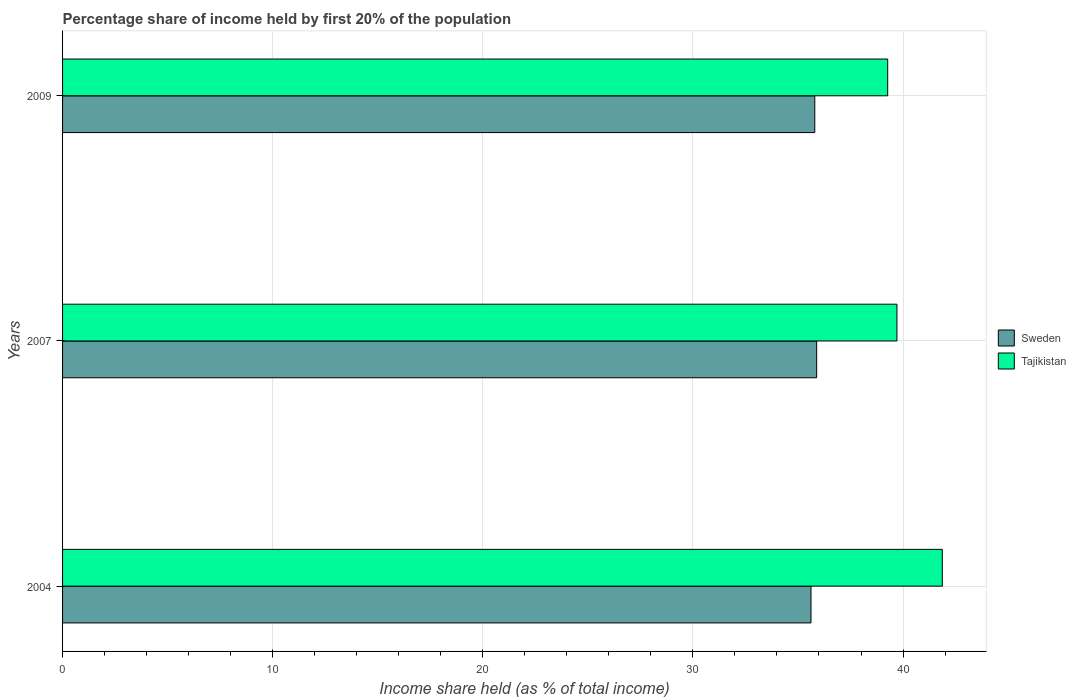Are the number of bars per tick equal to the number of legend labels?
Offer a terse response. Yes. What is the label of the 1st group of bars from the top?
Give a very brief answer. 2009. What is the share of income held by first 20% of the population in Sweden in 2004?
Offer a very short reply. 35.62. Across all years, what is the maximum share of income held by first 20% of the population in Sweden?
Provide a succinct answer. 35.89. Across all years, what is the minimum share of income held by first 20% of the population in Tajikistan?
Keep it short and to the point. 39.27. What is the total share of income held by first 20% of the population in Sweden in the graph?
Offer a terse response. 107.31. What is the difference between the share of income held by first 20% of the population in Tajikistan in 2004 and that in 2009?
Ensure brevity in your answer.  2.6. What is the difference between the share of income held by first 20% of the population in Tajikistan in 2009 and the share of income held by first 20% of the population in Sweden in 2007?
Give a very brief answer. 3.38. What is the average share of income held by first 20% of the population in Sweden per year?
Your response must be concise. 35.77. In the year 2009, what is the difference between the share of income held by first 20% of the population in Sweden and share of income held by first 20% of the population in Tajikistan?
Provide a succinct answer. -3.47. What is the ratio of the share of income held by first 20% of the population in Tajikistan in 2007 to that in 2009?
Provide a short and direct response. 1.01. Is the share of income held by first 20% of the population in Tajikistan in 2007 less than that in 2009?
Keep it short and to the point. No. What is the difference between the highest and the second highest share of income held by first 20% of the population in Tajikistan?
Provide a succinct answer. 2.16. What is the difference between the highest and the lowest share of income held by first 20% of the population in Sweden?
Your answer should be very brief. 0.27. In how many years, is the share of income held by first 20% of the population in Tajikistan greater than the average share of income held by first 20% of the population in Tajikistan taken over all years?
Make the answer very short. 1. Is the sum of the share of income held by first 20% of the population in Sweden in 2004 and 2009 greater than the maximum share of income held by first 20% of the population in Tajikistan across all years?
Provide a short and direct response. Yes. What does the 1st bar from the bottom in 2007 represents?
Provide a succinct answer. Sweden. How many bars are there?
Offer a terse response. 6. What is the difference between two consecutive major ticks on the X-axis?
Make the answer very short. 10. How are the legend labels stacked?
Offer a very short reply. Vertical. What is the title of the graph?
Give a very brief answer. Percentage share of income held by first 20% of the population. Does "Estonia" appear as one of the legend labels in the graph?
Make the answer very short. No. What is the label or title of the X-axis?
Offer a terse response. Income share held (as % of total income). What is the label or title of the Y-axis?
Make the answer very short. Years. What is the Income share held (as % of total income) of Sweden in 2004?
Your answer should be compact. 35.62. What is the Income share held (as % of total income) in Tajikistan in 2004?
Your answer should be very brief. 41.87. What is the Income share held (as % of total income) of Sweden in 2007?
Make the answer very short. 35.89. What is the Income share held (as % of total income) of Tajikistan in 2007?
Your answer should be compact. 39.71. What is the Income share held (as % of total income) of Sweden in 2009?
Keep it short and to the point. 35.8. What is the Income share held (as % of total income) in Tajikistan in 2009?
Give a very brief answer. 39.27. Across all years, what is the maximum Income share held (as % of total income) in Sweden?
Your answer should be compact. 35.89. Across all years, what is the maximum Income share held (as % of total income) in Tajikistan?
Offer a terse response. 41.87. Across all years, what is the minimum Income share held (as % of total income) in Sweden?
Ensure brevity in your answer.  35.62. Across all years, what is the minimum Income share held (as % of total income) in Tajikistan?
Make the answer very short. 39.27. What is the total Income share held (as % of total income) in Sweden in the graph?
Your response must be concise. 107.31. What is the total Income share held (as % of total income) of Tajikistan in the graph?
Offer a terse response. 120.85. What is the difference between the Income share held (as % of total income) in Sweden in 2004 and that in 2007?
Your answer should be very brief. -0.27. What is the difference between the Income share held (as % of total income) in Tajikistan in 2004 and that in 2007?
Make the answer very short. 2.16. What is the difference between the Income share held (as % of total income) of Sweden in 2004 and that in 2009?
Offer a terse response. -0.18. What is the difference between the Income share held (as % of total income) of Sweden in 2007 and that in 2009?
Make the answer very short. 0.09. What is the difference between the Income share held (as % of total income) of Tajikistan in 2007 and that in 2009?
Ensure brevity in your answer.  0.44. What is the difference between the Income share held (as % of total income) of Sweden in 2004 and the Income share held (as % of total income) of Tajikistan in 2007?
Ensure brevity in your answer.  -4.09. What is the difference between the Income share held (as % of total income) in Sweden in 2004 and the Income share held (as % of total income) in Tajikistan in 2009?
Provide a short and direct response. -3.65. What is the difference between the Income share held (as % of total income) of Sweden in 2007 and the Income share held (as % of total income) of Tajikistan in 2009?
Offer a very short reply. -3.38. What is the average Income share held (as % of total income) in Sweden per year?
Provide a succinct answer. 35.77. What is the average Income share held (as % of total income) in Tajikistan per year?
Your answer should be compact. 40.28. In the year 2004, what is the difference between the Income share held (as % of total income) in Sweden and Income share held (as % of total income) in Tajikistan?
Provide a succinct answer. -6.25. In the year 2007, what is the difference between the Income share held (as % of total income) of Sweden and Income share held (as % of total income) of Tajikistan?
Offer a very short reply. -3.82. In the year 2009, what is the difference between the Income share held (as % of total income) in Sweden and Income share held (as % of total income) in Tajikistan?
Give a very brief answer. -3.47. What is the ratio of the Income share held (as % of total income) of Sweden in 2004 to that in 2007?
Your response must be concise. 0.99. What is the ratio of the Income share held (as % of total income) of Tajikistan in 2004 to that in 2007?
Ensure brevity in your answer.  1.05. What is the ratio of the Income share held (as % of total income) in Tajikistan in 2004 to that in 2009?
Provide a succinct answer. 1.07. What is the ratio of the Income share held (as % of total income) of Tajikistan in 2007 to that in 2009?
Offer a very short reply. 1.01. What is the difference between the highest and the second highest Income share held (as % of total income) in Sweden?
Provide a short and direct response. 0.09. What is the difference between the highest and the second highest Income share held (as % of total income) in Tajikistan?
Ensure brevity in your answer.  2.16. What is the difference between the highest and the lowest Income share held (as % of total income) in Sweden?
Offer a terse response. 0.27. 